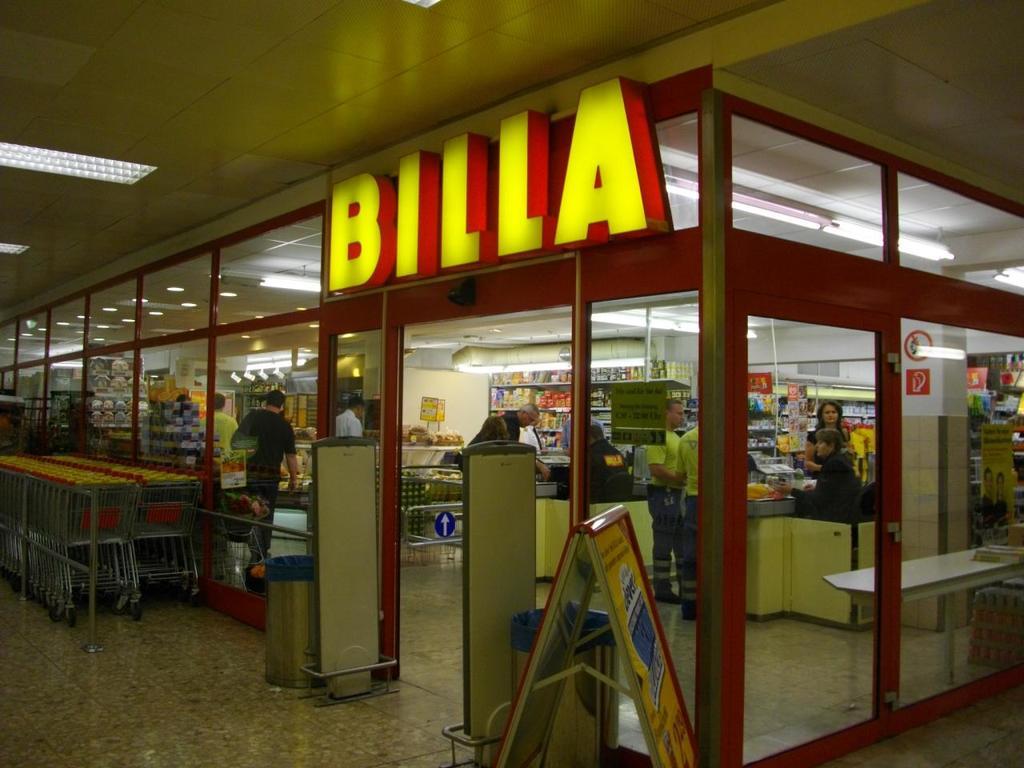What's the name of the store?
Your answer should be very brief. Billa. 